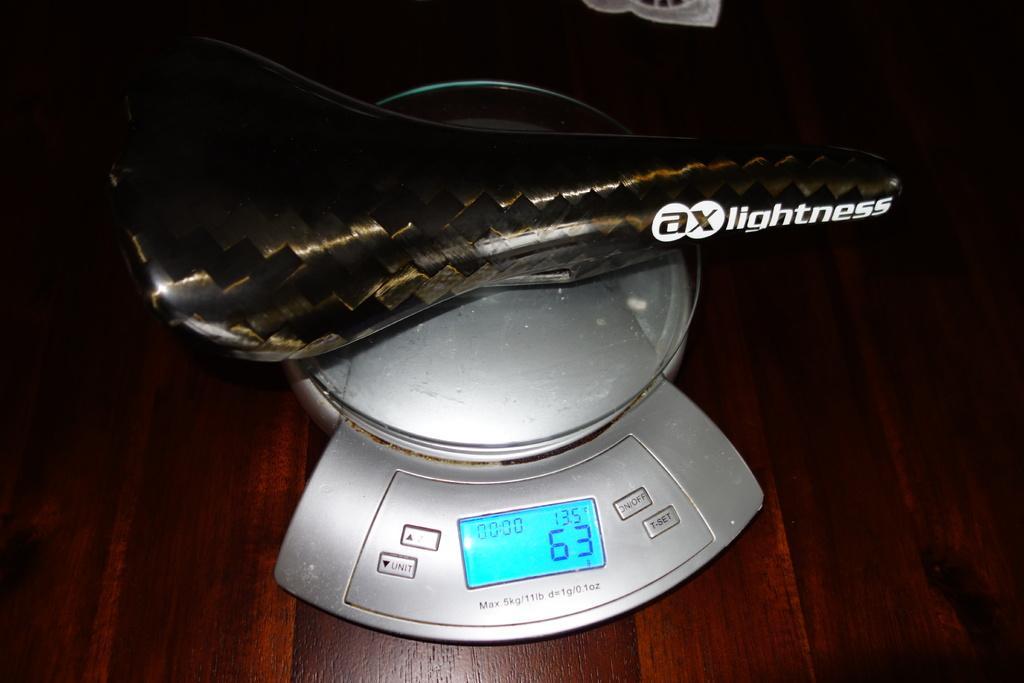Please provide a concise description of this image. In this image there is a weighing machine on a wooden surface. There are buttons and a digital display screen on the machine. There is text on the buttons. There are numbers displayed on the screen. There is an object on the machine. There is text on the object. 